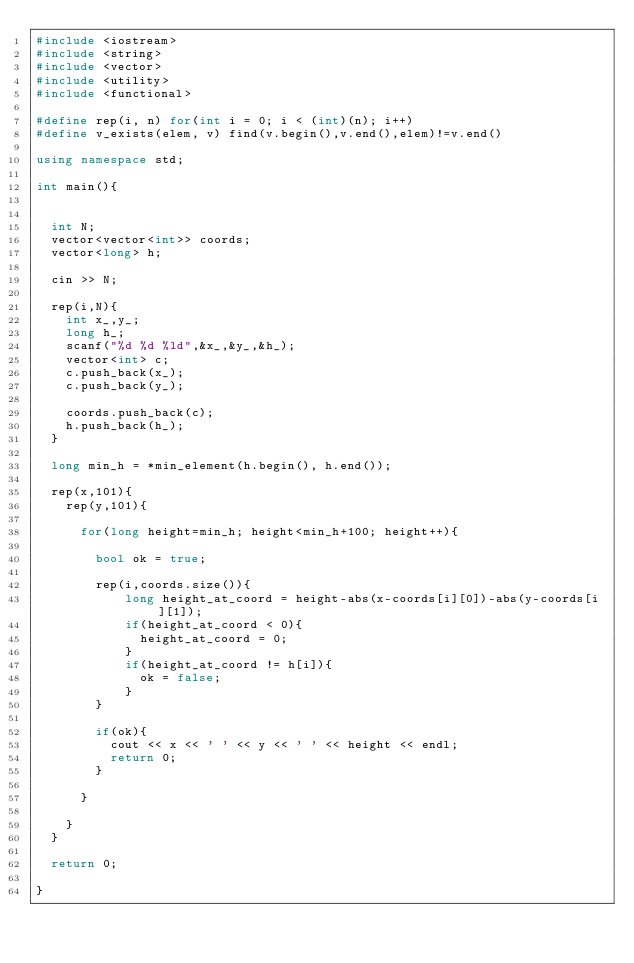Convert code to text. <code><loc_0><loc_0><loc_500><loc_500><_C++_>#include <iostream>
#include <string>
#include <vector>
#include <utility>
#include <functional>

#define rep(i, n) for(int i = 0; i < (int)(n); i++)
#define v_exists(elem, v) find(v.begin(),v.end(),elem)!=v.end()

using namespace std;

int main(){


  int N;
  vector<vector<int>> coords;
  vector<long> h;

  cin >> N;

  rep(i,N){
    int x_,y_;
    long h_;
    scanf("%d %d %ld",&x_,&y_,&h_);
    vector<int> c;
    c.push_back(x_);
    c.push_back(y_);

    coords.push_back(c);
    h.push_back(h_);
  }

  long min_h = *min_element(h.begin(), h.end());

  rep(x,101){
    rep(y,101){

      for(long height=min_h; height<min_h+100; height++){

        bool ok = true;

        rep(i,coords.size()){
            long height_at_coord = height-abs(x-coords[i][0])-abs(y-coords[i][1]);
            if(height_at_coord < 0){
              height_at_coord = 0;
            }
            if(height_at_coord != h[i]){
              ok = false;
            }
        }

        if(ok){
          cout << x << ' ' << y << ' ' << height << endl;
          return 0;
        }

      }

    }
  }

  return 0;

}</code> 